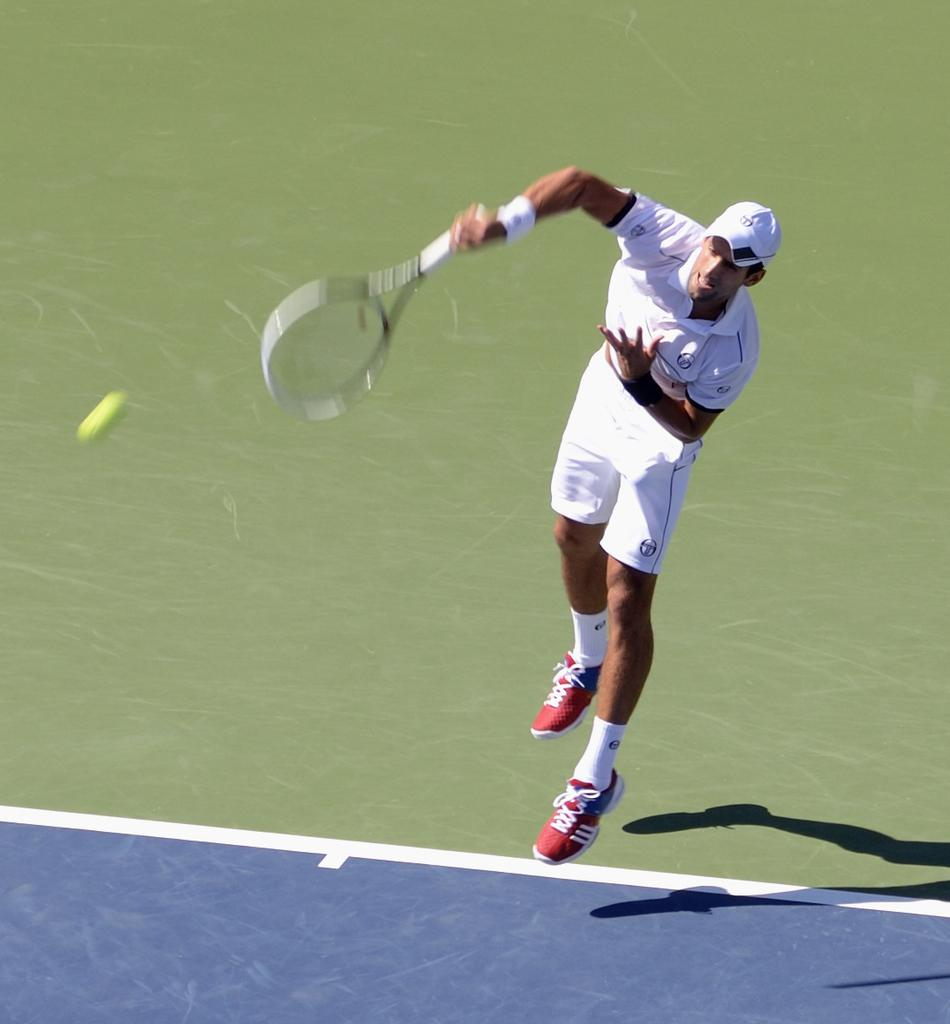What is the person in the image doing? The person is playing tennis. What is the person wearing while playing tennis? The person is wearing a white dress. What object is the person holding in the image? The person is holding a tennis racket. What action is the person performing in the image? The person is jumping in the air. What is in front of the person while playing tennis? There is a tennis ball in front of the person. How many cows are visible in the image? There are no cows present in the image. What type of truck can be seen in the background of the image? There is no truck visible in the image. 